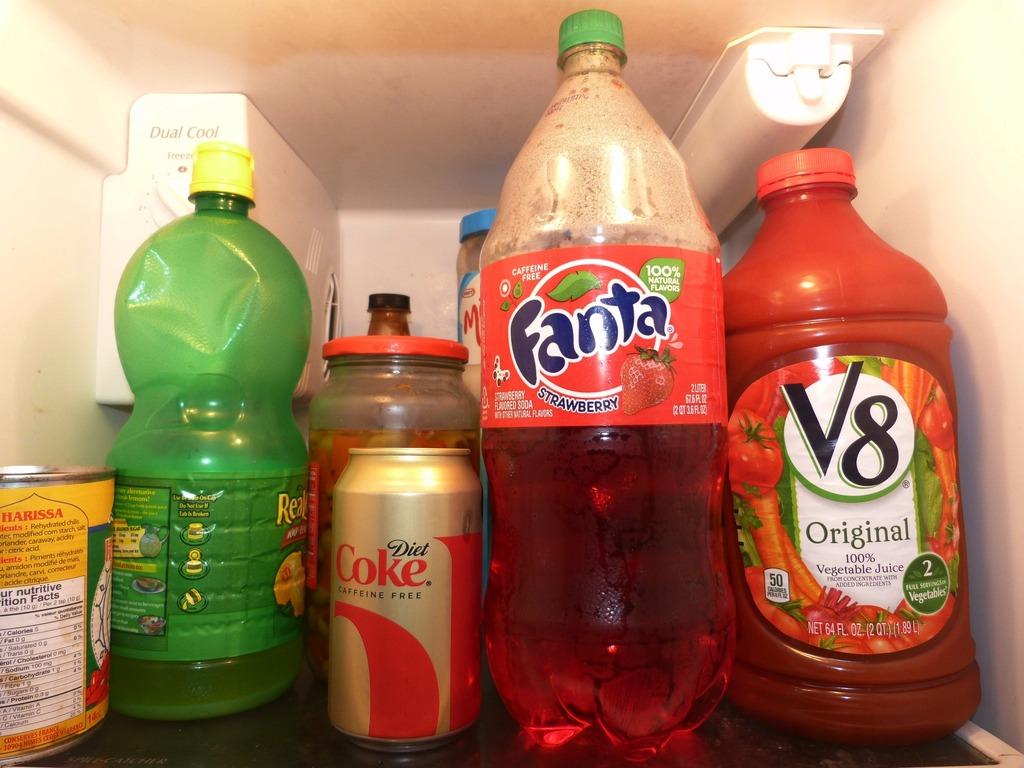Any diet drinks there?
Keep it short and to the point. Yes. What flavor of fanta?
Your answer should be very brief. Strawberry. 